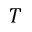Convert formula to latex. <formula><loc_0><loc_0><loc_500><loc_500>T</formula> 